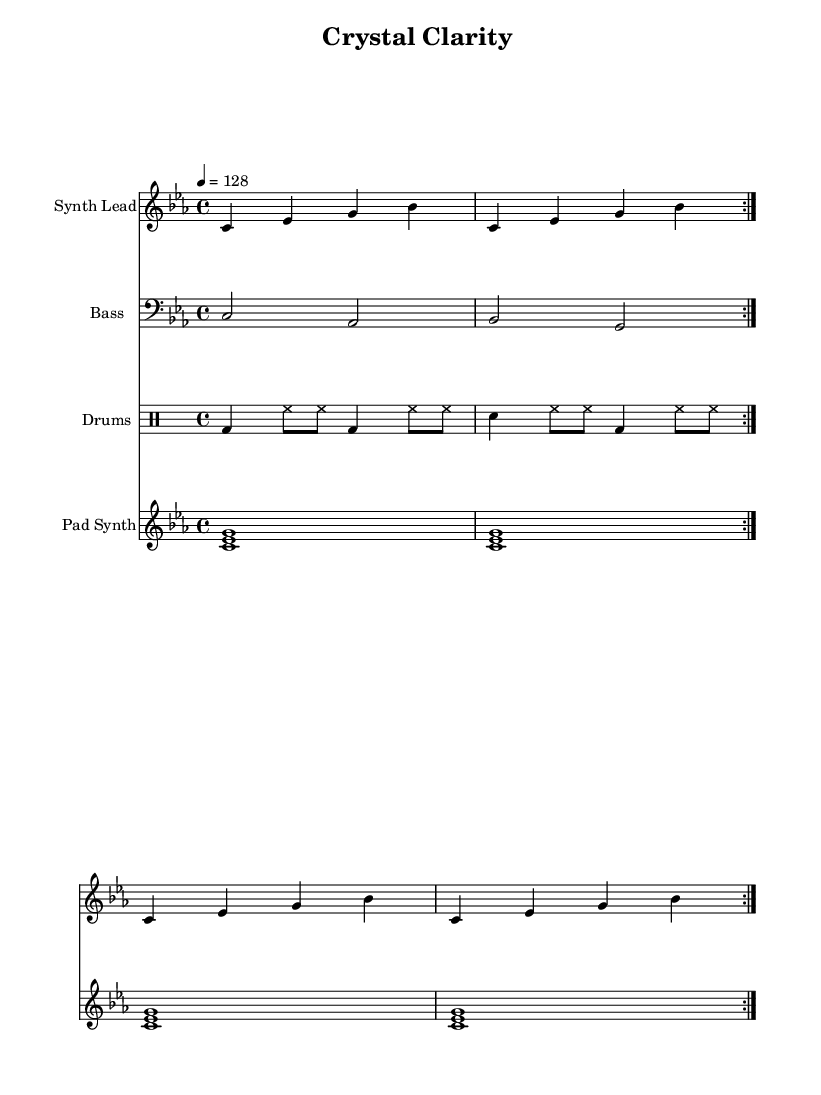What is the key signature of this music? The key signature is C minor, which has three flats (B, E, A) indicated at the beginning of the staff.
Answer: C minor What is the time signature of this piece? The time signature is displayed as 4/4, meaning there are four beats in each measure, and each quarter note gets one beat.
Answer: 4/4 What is the tempo marking for this composition? The tempo is marked as a quarter note equals 128 beats per minute, indicating the speed of the piece.
Answer: 128 How many measures are repeated in the synth lead part? The synth lead part has a repeated section which is shown with the volta markings, indicating two measures repeat.
Answer: Two measures What are the primary rhythmic elements in the drum pattern? The drum pattern includes a combination of bass drum, snare, and hi-hat notes, often arranged in a driving rhythm typical for house music.
Answer: Bass drum, snare, hi-hat Which harmonic subset is used in the pad synth part? The pad synth plays a major triad consisting of the root (C), the minor third (E-flat), and the perfect fifth (G) noted as chords.
Answer: C, E-flat, G What style of music is this piece associated with? This piece embodies Minimalist House music, characterized by clarity and rhythmic repetition in its instrumentation and structure.
Answer: Minimalist House music 